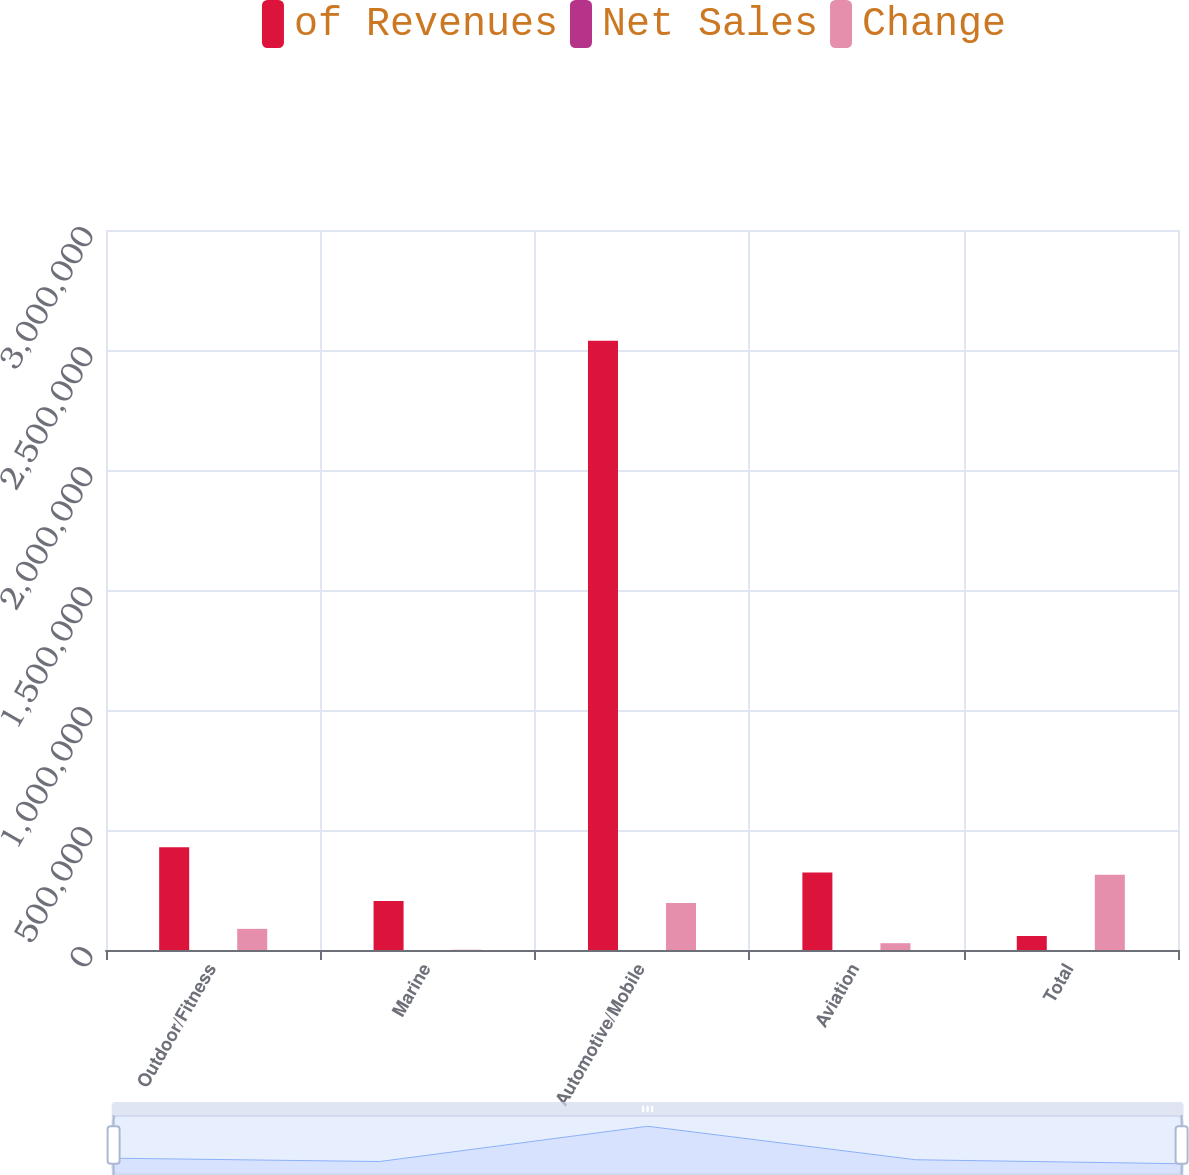Convert chart. <chart><loc_0><loc_0><loc_500><loc_500><stacked_bar_chart><ecel><fcel>Outdoor/Fitness<fcel>Marine<fcel>Automotive/Mobile<fcel>Aviation<fcel>Total<nl><fcel>of Revenues<fcel>427783<fcel>204477<fcel>2.53841e+06<fcel>323406<fcel>58226.5<nl><fcel>Net Sales<fcel>12.2<fcel>5.9<fcel>72.6<fcel>9.3<fcel>100<nl><fcel>Change<fcel>88042<fcel>1078<fcel>196227<fcel>28411<fcel>313758<nl></chart> 